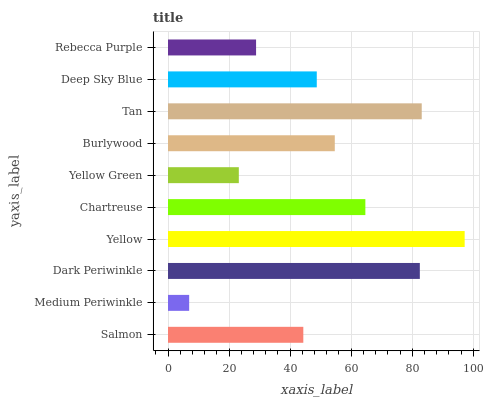Is Medium Periwinkle the minimum?
Answer yes or no. Yes. Is Yellow the maximum?
Answer yes or no. Yes. Is Dark Periwinkle the minimum?
Answer yes or no. No. Is Dark Periwinkle the maximum?
Answer yes or no. No. Is Dark Periwinkle greater than Medium Periwinkle?
Answer yes or no. Yes. Is Medium Periwinkle less than Dark Periwinkle?
Answer yes or no. Yes. Is Medium Periwinkle greater than Dark Periwinkle?
Answer yes or no. No. Is Dark Periwinkle less than Medium Periwinkle?
Answer yes or no. No. Is Burlywood the high median?
Answer yes or no. Yes. Is Deep Sky Blue the low median?
Answer yes or no. Yes. Is Rebecca Purple the high median?
Answer yes or no. No. Is Rebecca Purple the low median?
Answer yes or no. No. 